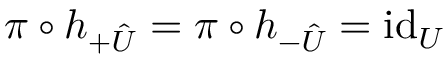<formula> <loc_0><loc_0><loc_500><loc_500>\pi \circ h _ { + \hat { U } } = \pi \circ h _ { - \hat { U } } = i d _ { U }</formula> 